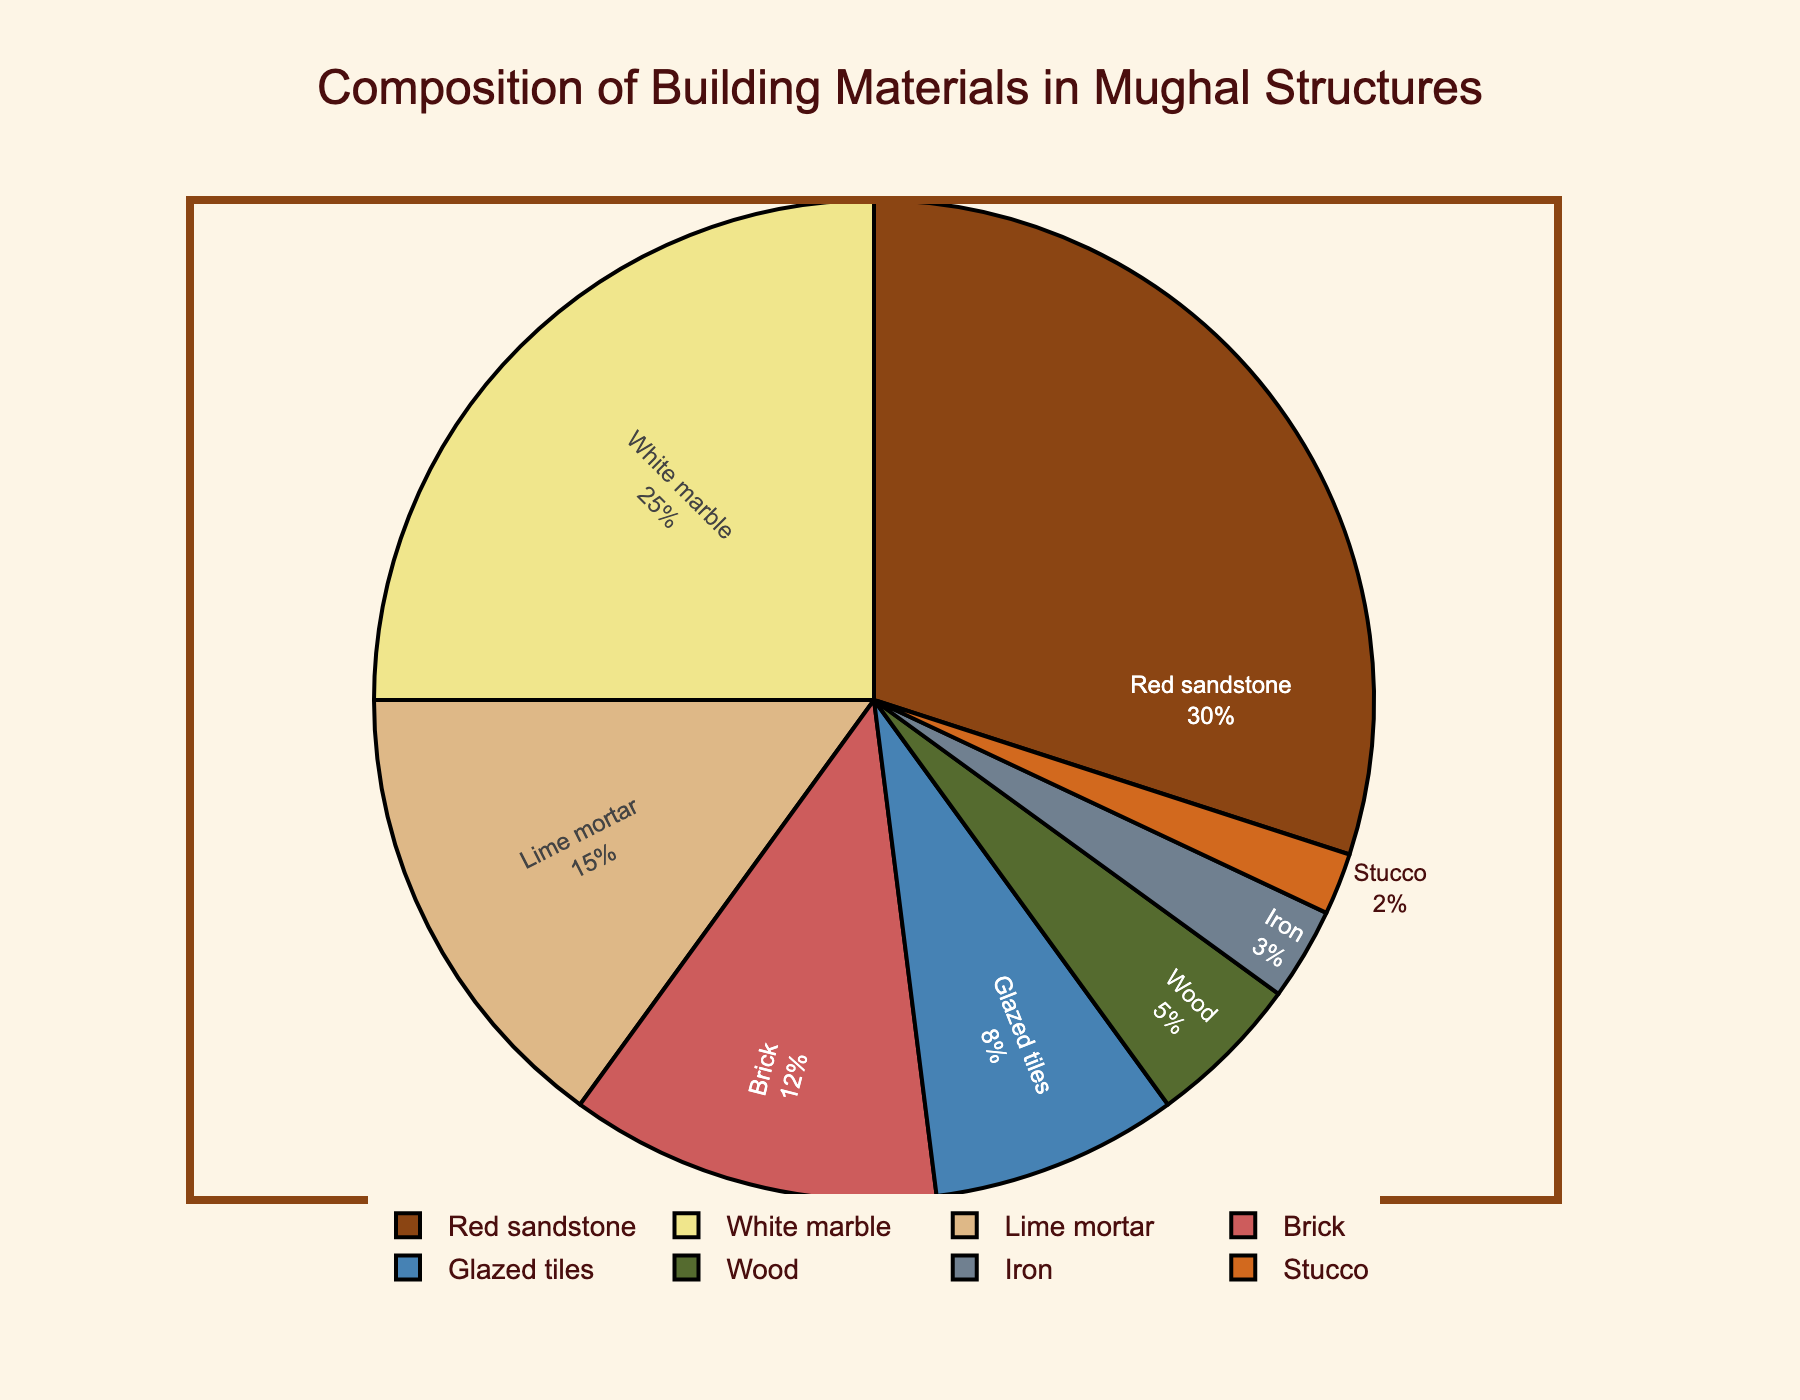What's the difference in percentage between Red sandstone and White marble? The percentage of Red sandstone is 30% and the percentage of White marble is 25%. The difference is 30 - 25 = 5%.
Answer: 5% Which material is used the least in Mughal structures? The material with the lowest percentage used in Mughal structures is Stucco, with 2%.
Answer: Stucco What is the combined percentage of Brick and Glazed tiles? The percentage of Brick is 12%, and the percentage of Glazed tiles is 8%. The combined percentage is 12 + 8 = 20%.
Answer: 20% Between Lime mortar and Wood, which one has a higher percentage, and by how much? The percentage of Lime mortar is 15%, and the percentage of Wood is 5%. Lime mortar has a higher percentage by 15 - 5 = 10%.
Answer: Lime mortar, by 10% Which material represents approximately a quarter of the composition? The material that represents approximately a quarter of the composition is White marble with 25%.
Answer: White marble If Red sandstone and White marble together account for more than half of the composition, what is their combined percentage? The percentage of Red sandstone is 30%, and the percentage of White marble is 25%. Their combined percentage is 30 + 25 = 55%, which is more than half of the composition (50%).
Answer: 55% Which materials have a combined percentage less than that of Red sandstone alone? The percentages of Iron, Stucco, and Wood are 3%, 2%, and 5%, respectively. Their combined percentage is 3 + 2 + 5 = 10%. Another combination with a percentage less than that of Red sandstone alone (30%) is Glazed tiles and Wood, with percentages of 8% and 5%, respectively, adding to 8 + 5 = 13%.
Answer: Iron, Stucco, and Wood; Glazed tiles and Wood What is the total percentage of materials other than Red sandstone, White marble, and Lime mortar? The total percentage of all materials is 100%. Subtracting the percentages of Red sandstone (30%), White marble (25%), and Lime mortar (15%) gives 100 - (30 + 25 + 15) = 30%.
Answer: 30% By how much does the percentage of Glazed tiles exceed the percentage of Iron? The percentage of Glazed tiles is 8%, and the percentage of Iron is 3%. The amount by which Glazed tiles exceed Iron is 8 - 3 = 5%.
Answer: 5% What is the combined percentage of Wood, Iron, and Stucco? The percentages of Wood, Iron, and Stucco are 5%, 3%, and 2%, respectively. Their combined percentage is 5 + 3 + 2 = 10%.
Answer: 10% 